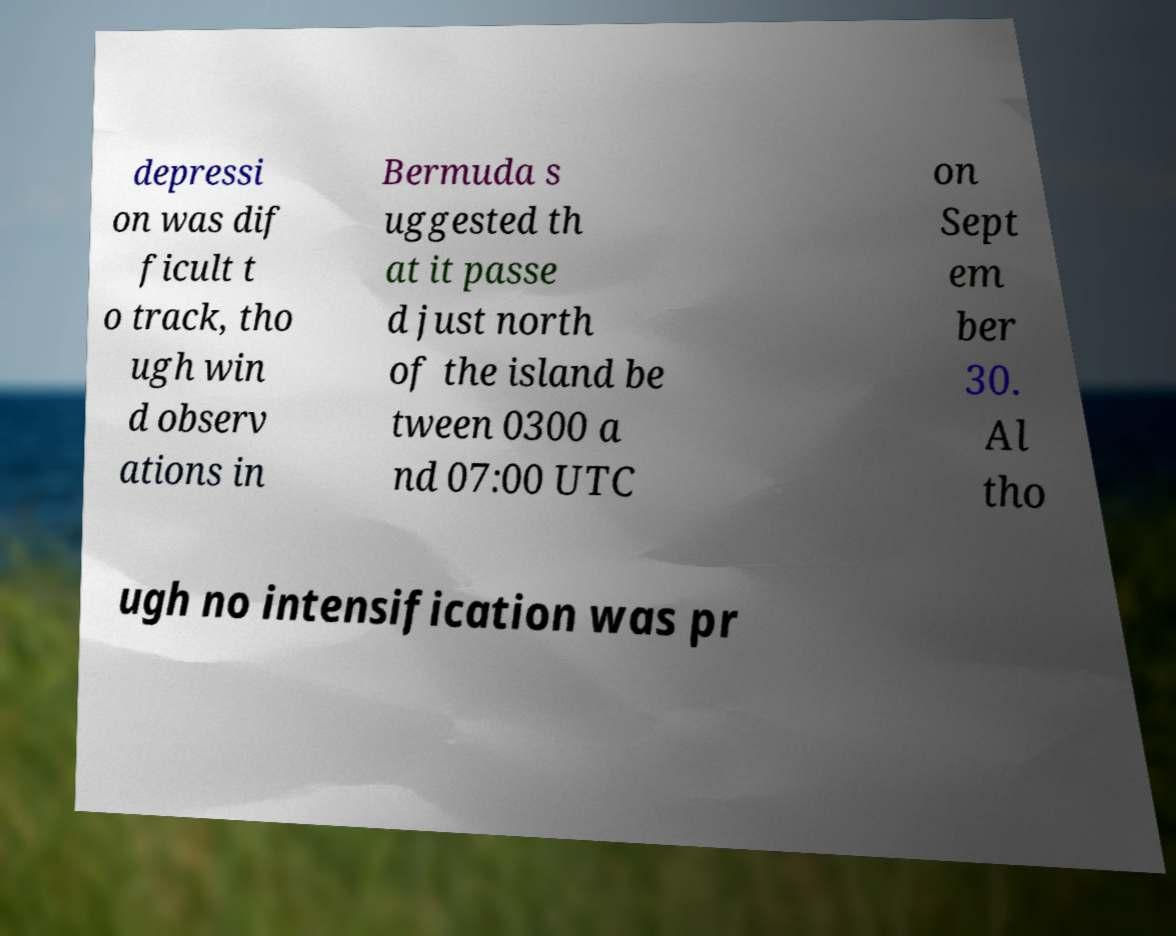What messages or text are displayed in this image? I need them in a readable, typed format. depressi on was dif ficult t o track, tho ugh win d observ ations in Bermuda s uggested th at it passe d just north of the island be tween 0300 a nd 07:00 UTC on Sept em ber 30. Al tho ugh no intensification was pr 